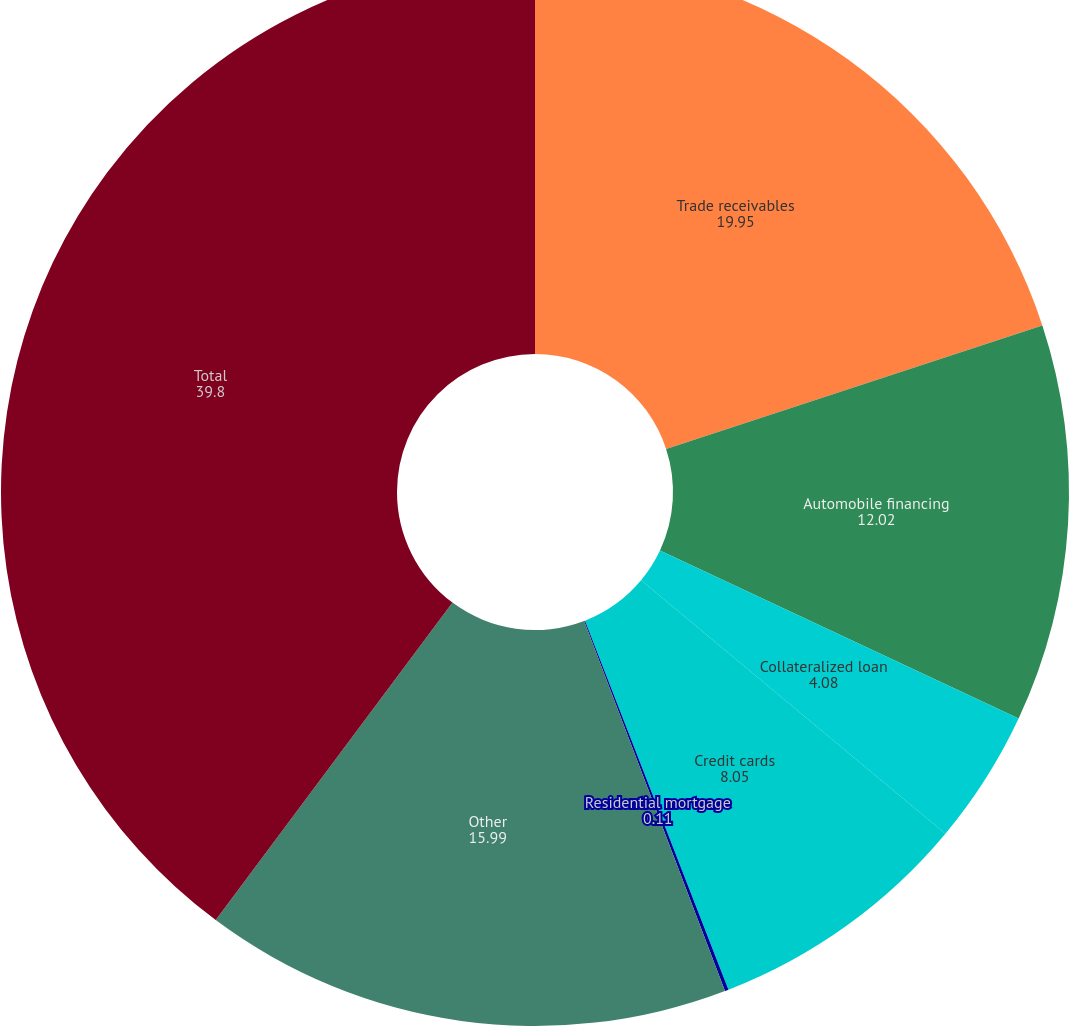Convert chart. <chart><loc_0><loc_0><loc_500><loc_500><pie_chart><fcel>Trade receivables<fcel>Automobile financing<fcel>Collateralized loan<fcel>Credit cards<fcel>Residential mortgage<fcel>Other<fcel>Total<nl><fcel>19.95%<fcel>12.02%<fcel>4.08%<fcel>8.05%<fcel>0.11%<fcel>15.99%<fcel>39.8%<nl></chart> 